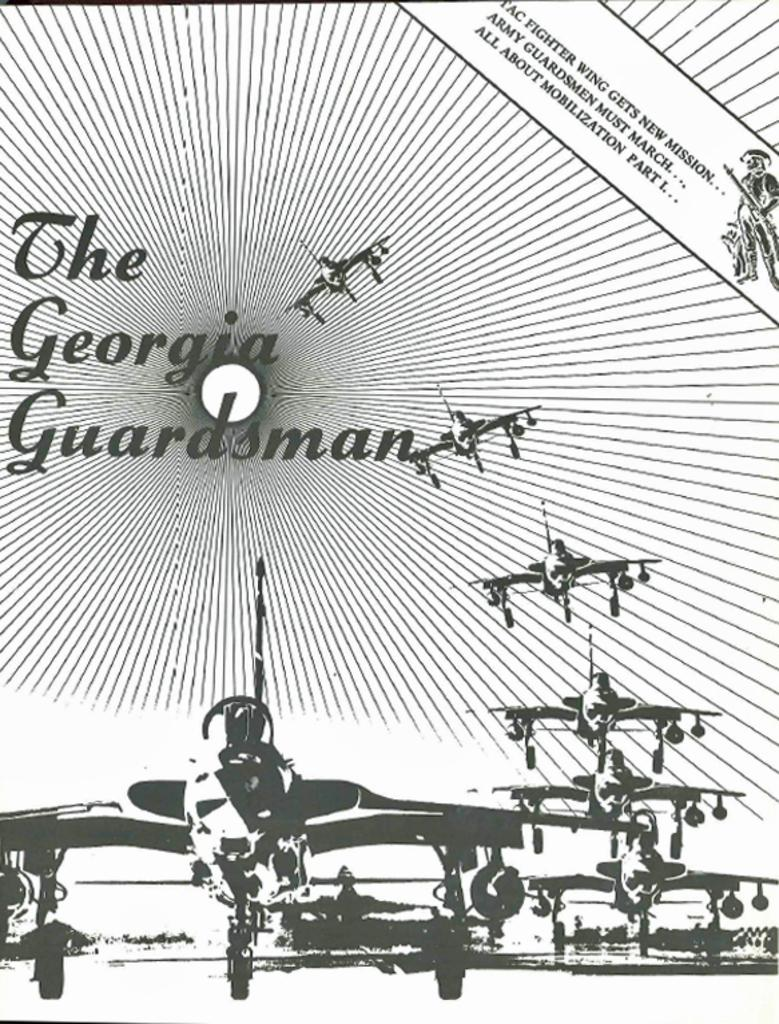What is the main subject of the image? The main subject of the image is aircrafts. Are there any specific details on the aircrafts? Yes, there is text written on the aircrafts. What is the color scheme of the image? The image is in black and white. Can you tell me how many flowers are depicted on the aircrafts in the image? There are no flowers depicted on the aircrafts in the image; the image is in black and white and features text on the aircrafts. 